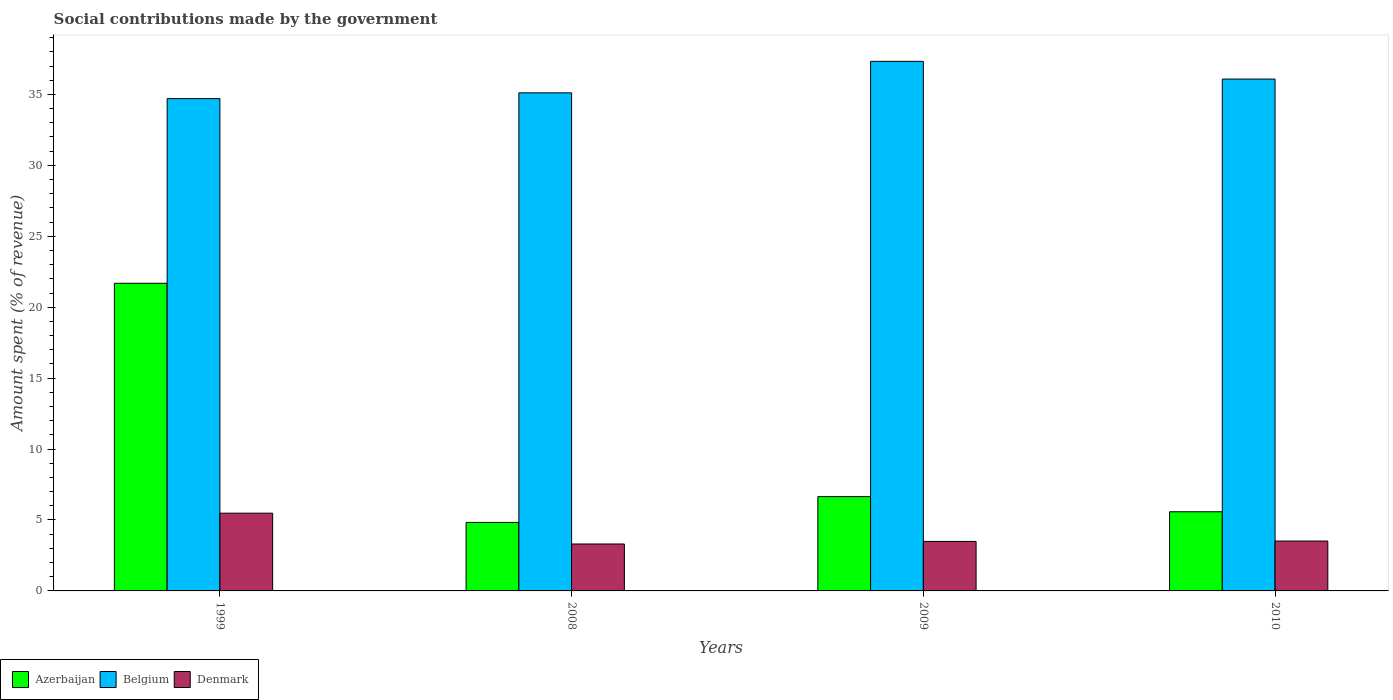How many different coloured bars are there?
Ensure brevity in your answer.  3. How many groups of bars are there?
Your answer should be compact. 4. How many bars are there on the 4th tick from the left?
Provide a succinct answer. 3. In how many cases, is the number of bars for a given year not equal to the number of legend labels?
Give a very brief answer. 0. What is the amount spent (in %) on social contributions in Azerbaijan in 2010?
Offer a terse response. 5.58. Across all years, what is the maximum amount spent (in %) on social contributions in Belgium?
Your answer should be compact. 37.33. Across all years, what is the minimum amount spent (in %) on social contributions in Belgium?
Give a very brief answer. 34.7. What is the total amount spent (in %) on social contributions in Denmark in the graph?
Ensure brevity in your answer.  15.79. What is the difference between the amount spent (in %) on social contributions in Denmark in 2009 and that in 2010?
Offer a very short reply. -0.03. What is the difference between the amount spent (in %) on social contributions in Belgium in 2008 and the amount spent (in %) on social contributions in Azerbaijan in 1999?
Provide a succinct answer. 13.42. What is the average amount spent (in %) on social contributions in Denmark per year?
Your answer should be compact. 3.95. In the year 2010, what is the difference between the amount spent (in %) on social contributions in Denmark and amount spent (in %) on social contributions in Azerbaijan?
Provide a succinct answer. -2.06. In how many years, is the amount spent (in %) on social contributions in Belgium greater than 13 %?
Make the answer very short. 4. What is the ratio of the amount spent (in %) on social contributions in Belgium in 2008 to that in 2009?
Ensure brevity in your answer.  0.94. What is the difference between the highest and the second highest amount spent (in %) on social contributions in Belgium?
Your answer should be very brief. 1.25. What is the difference between the highest and the lowest amount spent (in %) on social contributions in Azerbaijan?
Your answer should be compact. 16.86. In how many years, is the amount spent (in %) on social contributions in Belgium greater than the average amount spent (in %) on social contributions in Belgium taken over all years?
Keep it short and to the point. 2. Is the sum of the amount spent (in %) on social contributions in Azerbaijan in 1999 and 2010 greater than the maximum amount spent (in %) on social contributions in Belgium across all years?
Keep it short and to the point. No. What does the 3rd bar from the left in 2008 represents?
Offer a very short reply. Denmark. What does the 3rd bar from the right in 2009 represents?
Ensure brevity in your answer.  Azerbaijan. How many years are there in the graph?
Ensure brevity in your answer.  4. What is the difference between two consecutive major ticks on the Y-axis?
Your response must be concise. 5. Does the graph contain grids?
Your answer should be very brief. No. Where does the legend appear in the graph?
Offer a very short reply. Bottom left. How many legend labels are there?
Offer a very short reply. 3. How are the legend labels stacked?
Your response must be concise. Horizontal. What is the title of the graph?
Offer a terse response. Social contributions made by the government. What is the label or title of the X-axis?
Offer a terse response. Years. What is the label or title of the Y-axis?
Provide a short and direct response. Amount spent (% of revenue). What is the Amount spent (% of revenue) of Azerbaijan in 1999?
Ensure brevity in your answer.  21.69. What is the Amount spent (% of revenue) of Belgium in 1999?
Ensure brevity in your answer.  34.7. What is the Amount spent (% of revenue) of Denmark in 1999?
Provide a short and direct response. 5.48. What is the Amount spent (% of revenue) in Azerbaijan in 2008?
Provide a succinct answer. 4.83. What is the Amount spent (% of revenue) of Belgium in 2008?
Your response must be concise. 35.11. What is the Amount spent (% of revenue) of Denmark in 2008?
Keep it short and to the point. 3.31. What is the Amount spent (% of revenue) of Azerbaijan in 2009?
Give a very brief answer. 6.65. What is the Amount spent (% of revenue) of Belgium in 2009?
Provide a short and direct response. 37.33. What is the Amount spent (% of revenue) in Denmark in 2009?
Provide a succinct answer. 3.49. What is the Amount spent (% of revenue) of Azerbaijan in 2010?
Your answer should be compact. 5.58. What is the Amount spent (% of revenue) in Belgium in 2010?
Provide a succinct answer. 36.08. What is the Amount spent (% of revenue) in Denmark in 2010?
Your response must be concise. 3.52. Across all years, what is the maximum Amount spent (% of revenue) in Azerbaijan?
Make the answer very short. 21.69. Across all years, what is the maximum Amount spent (% of revenue) in Belgium?
Your response must be concise. 37.33. Across all years, what is the maximum Amount spent (% of revenue) in Denmark?
Make the answer very short. 5.48. Across all years, what is the minimum Amount spent (% of revenue) of Azerbaijan?
Your response must be concise. 4.83. Across all years, what is the minimum Amount spent (% of revenue) in Belgium?
Provide a short and direct response. 34.7. Across all years, what is the minimum Amount spent (% of revenue) in Denmark?
Give a very brief answer. 3.31. What is the total Amount spent (% of revenue) of Azerbaijan in the graph?
Your answer should be very brief. 38.74. What is the total Amount spent (% of revenue) in Belgium in the graph?
Keep it short and to the point. 143.22. What is the total Amount spent (% of revenue) of Denmark in the graph?
Give a very brief answer. 15.79. What is the difference between the Amount spent (% of revenue) of Azerbaijan in 1999 and that in 2008?
Your answer should be compact. 16.86. What is the difference between the Amount spent (% of revenue) of Belgium in 1999 and that in 2008?
Ensure brevity in your answer.  -0.4. What is the difference between the Amount spent (% of revenue) of Denmark in 1999 and that in 2008?
Offer a very short reply. 2.17. What is the difference between the Amount spent (% of revenue) in Azerbaijan in 1999 and that in 2009?
Your answer should be very brief. 15.04. What is the difference between the Amount spent (% of revenue) in Belgium in 1999 and that in 2009?
Provide a succinct answer. -2.63. What is the difference between the Amount spent (% of revenue) of Denmark in 1999 and that in 2009?
Give a very brief answer. 1.99. What is the difference between the Amount spent (% of revenue) in Azerbaijan in 1999 and that in 2010?
Your answer should be compact. 16.1. What is the difference between the Amount spent (% of revenue) in Belgium in 1999 and that in 2010?
Make the answer very short. -1.38. What is the difference between the Amount spent (% of revenue) of Denmark in 1999 and that in 2010?
Keep it short and to the point. 1.96. What is the difference between the Amount spent (% of revenue) of Azerbaijan in 2008 and that in 2009?
Offer a terse response. -1.82. What is the difference between the Amount spent (% of revenue) of Belgium in 2008 and that in 2009?
Your answer should be very brief. -2.22. What is the difference between the Amount spent (% of revenue) in Denmark in 2008 and that in 2009?
Keep it short and to the point. -0.18. What is the difference between the Amount spent (% of revenue) of Azerbaijan in 2008 and that in 2010?
Your answer should be very brief. -0.75. What is the difference between the Amount spent (% of revenue) of Belgium in 2008 and that in 2010?
Offer a terse response. -0.97. What is the difference between the Amount spent (% of revenue) in Denmark in 2008 and that in 2010?
Make the answer very short. -0.21. What is the difference between the Amount spent (% of revenue) in Azerbaijan in 2009 and that in 2010?
Provide a succinct answer. 1.07. What is the difference between the Amount spent (% of revenue) of Belgium in 2009 and that in 2010?
Your response must be concise. 1.25. What is the difference between the Amount spent (% of revenue) of Denmark in 2009 and that in 2010?
Your answer should be compact. -0.03. What is the difference between the Amount spent (% of revenue) in Azerbaijan in 1999 and the Amount spent (% of revenue) in Belgium in 2008?
Your answer should be very brief. -13.42. What is the difference between the Amount spent (% of revenue) of Azerbaijan in 1999 and the Amount spent (% of revenue) of Denmark in 2008?
Your answer should be very brief. 18.38. What is the difference between the Amount spent (% of revenue) of Belgium in 1999 and the Amount spent (% of revenue) of Denmark in 2008?
Offer a very short reply. 31.4. What is the difference between the Amount spent (% of revenue) of Azerbaijan in 1999 and the Amount spent (% of revenue) of Belgium in 2009?
Your answer should be very brief. -15.64. What is the difference between the Amount spent (% of revenue) in Azerbaijan in 1999 and the Amount spent (% of revenue) in Denmark in 2009?
Give a very brief answer. 18.2. What is the difference between the Amount spent (% of revenue) in Belgium in 1999 and the Amount spent (% of revenue) in Denmark in 2009?
Keep it short and to the point. 31.21. What is the difference between the Amount spent (% of revenue) in Azerbaijan in 1999 and the Amount spent (% of revenue) in Belgium in 2010?
Keep it short and to the point. -14.39. What is the difference between the Amount spent (% of revenue) of Azerbaijan in 1999 and the Amount spent (% of revenue) of Denmark in 2010?
Offer a very short reply. 18.17. What is the difference between the Amount spent (% of revenue) of Belgium in 1999 and the Amount spent (% of revenue) of Denmark in 2010?
Provide a succinct answer. 31.19. What is the difference between the Amount spent (% of revenue) in Azerbaijan in 2008 and the Amount spent (% of revenue) in Belgium in 2009?
Make the answer very short. -32.5. What is the difference between the Amount spent (% of revenue) of Azerbaijan in 2008 and the Amount spent (% of revenue) of Denmark in 2009?
Give a very brief answer. 1.34. What is the difference between the Amount spent (% of revenue) of Belgium in 2008 and the Amount spent (% of revenue) of Denmark in 2009?
Provide a succinct answer. 31.62. What is the difference between the Amount spent (% of revenue) of Azerbaijan in 2008 and the Amount spent (% of revenue) of Belgium in 2010?
Your response must be concise. -31.25. What is the difference between the Amount spent (% of revenue) of Azerbaijan in 2008 and the Amount spent (% of revenue) of Denmark in 2010?
Your answer should be compact. 1.31. What is the difference between the Amount spent (% of revenue) in Belgium in 2008 and the Amount spent (% of revenue) in Denmark in 2010?
Ensure brevity in your answer.  31.59. What is the difference between the Amount spent (% of revenue) of Azerbaijan in 2009 and the Amount spent (% of revenue) of Belgium in 2010?
Offer a terse response. -29.43. What is the difference between the Amount spent (% of revenue) in Azerbaijan in 2009 and the Amount spent (% of revenue) in Denmark in 2010?
Ensure brevity in your answer.  3.13. What is the difference between the Amount spent (% of revenue) in Belgium in 2009 and the Amount spent (% of revenue) in Denmark in 2010?
Offer a very short reply. 33.81. What is the average Amount spent (% of revenue) in Azerbaijan per year?
Provide a short and direct response. 9.69. What is the average Amount spent (% of revenue) in Belgium per year?
Offer a very short reply. 35.81. What is the average Amount spent (% of revenue) of Denmark per year?
Your answer should be very brief. 3.95. In the year 1999, what is the difference between the Amount spent (% of revenue) of Azerbaijan and Amount spent (% of revenue) of Belgium?
Offer a very short reply. -13.02. In the year 1999, what is the difference between the Amount spent (% of revenue) in Azerbaijan and Amount spent (% of revenue) in Denmark?
Give a very brief answer. 16.21. In the year 1999, what is the difference between the Amount spent (% of revenue) of Belgium and Amount spent (% of revenue) of Denmark?
Provide a short and direct response. 29.22. In the year 2008, what is the difference between the Amount spent (% of revenue) in Azerbaijan and Amount spent (% of revenue) in Belgium?
Your answer should be compact. -30.28. In the year 2008, what is the difference between the Amount spent (% of revenue) of Azerbaijan and Amount spent (% of revenue) of Denmark?
Make the answer very short. 1.52. In the year 2008, what is the difference between the Amount spent (% of revenue) of Belgium and Amount spent (% of revenue) of Denmark?
Provide a short and direct response. 31.8. In the year 2009, what is the difference between the Amount spent (% of revenue) of Azerbaijan and Amount spent (% of revenue) of Belgium?
Provide a succinct answer. -30.68. In the year 2009, what is the difference between the Amount spent (% of revenue) of Azerbaijan and Amount spent (% of revenue) of Denmark?
Make the answer very short. 3.16. In the year 2009, what is the difference between the Amount spent (% of revenue) of Belgium and Amount spent (% of revenue) of Denmark?
Keep it short and to the point. 33.84. In the year 2010, what is the difference between the Amount spent (% of revenue) in Azerbaijan and Amount spent (% of revenue) in Belgium?
Give a very brief answer. -30.5. In the year 2010, what is the difference between the Amount spent (% of revenue) of Azerbaijan and Amount spent (% of revenue) of Denmark?
Your response must be concise. 2.06. In the year 2010, what is the difference between the Amount spent (% of revenue) in Belgium and Amount spent (% of revenue) in Denmark?
Provide a succinct answer. 32.56. What is the ratio of the Amount spent (% of revenue) in Azerbaijan in 1999 to that in 2008?
Keep it short and to the point. 4.49. What is the ratio of the Amount spent (% of revenue) in Denmark in 1999 to that in 2008?
Your answer should be compact. 1.66. What is the ratio of the Amount spent (% of revenue) of Azerbaijan in 1999 to that in 2009?
Provide a short and direct response. 3.26. What is the ratio of the Amount spent (% of revenue) of Belgium in 1999 to that in 2009?
Your answer should be compact. 0.93. What is the ratio of the Amount spent (% of revenue) of Denmark in 1999 to that in 2009?
Offer a very short reply. 1.57. What is the ratio of the Amount spent (% of revenue) of Azerbaijan in 1999 to that in 2010?
Your answer should be very brief. 3.89. What is the ratio of the Amount spent (% of revenue) of Belgium in 1999 to that in 2010?
Your answer should be compact. 0.96. What is the ratio of the Amount spent (% of revenue) of Denmark in 1999 to that in 2010?
Offer a very short reply. 1.56. What is the ratio of the Amount spent (% of revenue) of Azerbaijan in 2008 to that in 2009?
Ensure brevity in your answer.  0.73. What is the ratio of the Amount spent (% of revenue) in Belgium in 2008 to that in 2009?
Offer a very short reply. 0.94. What is the ratio of the Amount spent (% of revenue) in Denmark in 2008 to that in 2009?
Keep it short and to the point. 0.95. What is the ratio of the Amount spent (% of revenue) of Azerbaijan in 2008 to that in 2010?
Offer a very short reply. 0.87. What is the ratio of the Amount spent (% of revenue) of Belgium in 2008 to that in 2010?
Offer a terse response. 0.97. What is the ratio of the Amount spent (% of revenue) of Denmark in 2008 to that in 2010?
Your answer should be compact. 0.94. What is the ratio of the Amount spent (% of revenue) of Azerbaijan in 2009 to that in 2010?
Your answer should be compact. 1.19. What is the ratio of the Amount spent (% of revenue) in Belgium in 2009 to that in 2010?
Your response must be concise. 1.03. What is the difference between the highest and the second highest Amount spent (% of revenue) of Azerbaijan?
Offer a very short reply. 15.04. What is the difference between the highest and the second highest Amount spent (% of revenue) of Belgium?
Offer a terse response. 1.25. What is the difference between the highest and the second highest Amount spent (% of revenue) of Denmark?
Offer a very short reply. 1.96. What is the difference between the highest and the lowest Amount spent (% of revenue) of Azerbaijan?
Make the answer very short. 16.86. What is the difference between the highest and the lowest Amount spent (% of revenue) in Belgium?
Your response must be concise. 2.63. What is the difference between the highest and the lowest Amount spent (% of revenue) of Denmark?
Make the answer very short. 2.17. 